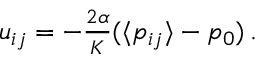<formula> <loc_0><loc_0><loc_500><loc_500>\begin{array} { r } { u _ { i j } = - \frac { 2 \alpha } { K } ( \langle p _ { i j } \rangle - p _ { 0 } ) \, . } \end{array}</formula> 